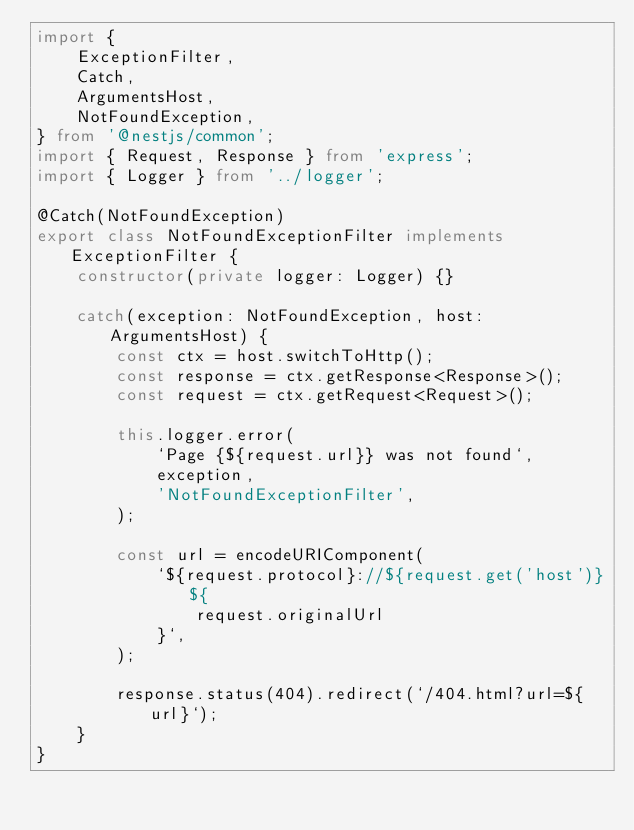<code> <loc_0><loc_0><loc_500><loc_500><_TypeScript_>import {
    ExceptionFilter,
    Catch,
    ArgumentsHost,
    NotFoundException,
} from '@nestjs/common';
import { Request, Response } from 'express';
import { Logger } from '../logger';

@Catch(NotFoundException)
export class NotFoundExceptionFilter implements ExceptionFilter {
    constructor(private logger: Logger) {}

    catch(exception: NotFoundException, host: ArgumentsHost) {
        const ctx = host.switchToHttp();
        const response = ctx.getResponse<Response>();
        const request = ctx.getRequest<Request>();

        this.logger.error(
            `Page {${request.url}} was not found`,
            exception,
            'NotFoundExceptionFilter',
        );

        const url = encodeURIComponent(
            `${request.protocol}://${request.get('host')}${
                request.originalUrl
            }`,
        );

        response.status(404).redirect(`/404.html?url=${url}`);
    }
}
</code> 